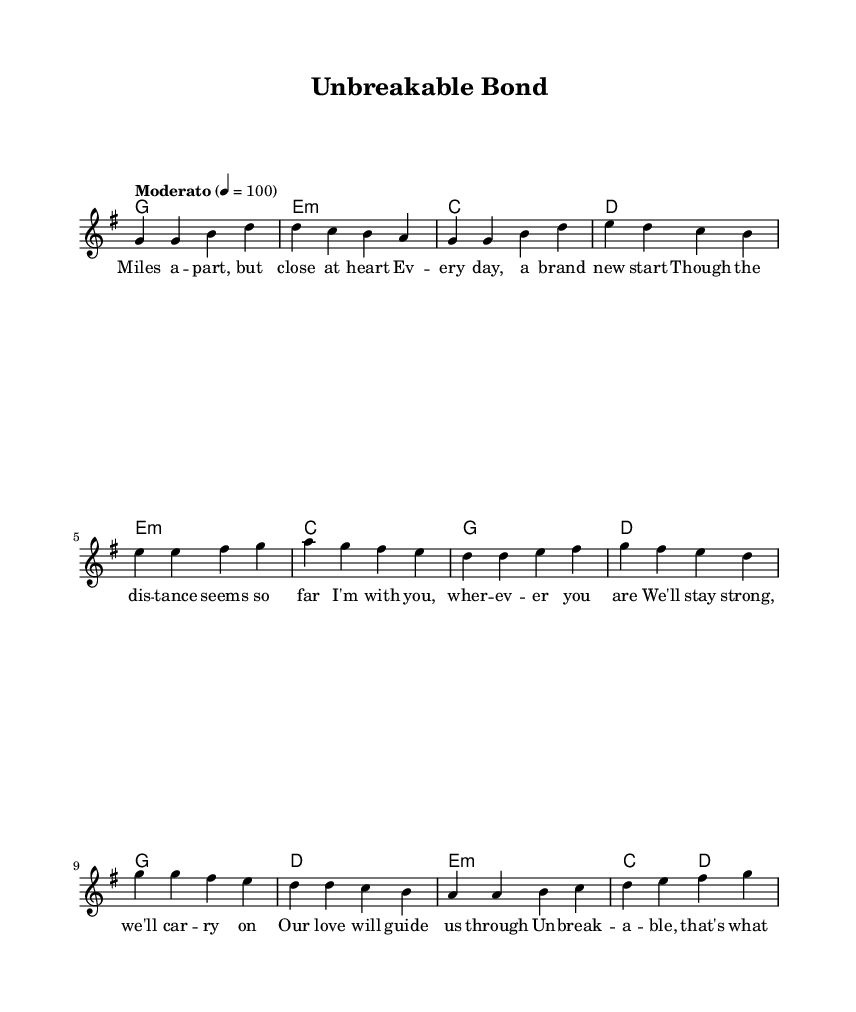What is the key signature of this music? The key signature is G major, which contains one sharp, F sharp. This can be determined by looking at the key signature at the beginning of the score.
Answer: G major What is the time signature of this music? The time signature is 4/4, which indicates four beats per measure. This can be identified at the beginning of the score next to the key signature.
Answer: 4/4 What is the tempo marking of the piece? The tempo marking is "Moderato", which indicates a moderate speed of the music. This is stated at the beginning of the score.
Answer: Moderato How many measures are in the chorus section? The chorus section contains four measures. By counting the individual measures specified in the music notation, we can determine this total.
Answer: 4 What is the initial note of the verse? The initial note of the verse is G. This can be observed as the first note in the melody part of the verse.
Answer: G How many vocal lines are present in the score? The score features one vocal line, which is denoted as "lead". This is visible in the score structure where only one voice is indicated.
Answer: One What lyrical theme is expressed in the chorus? The lyrical theme expressed in the chorus is about resilience and unity. The lyrics emphasize being "unbreakable" and overcoming challenges together, highlighting themes of strength and connection.
Answer: Resilience and unity 